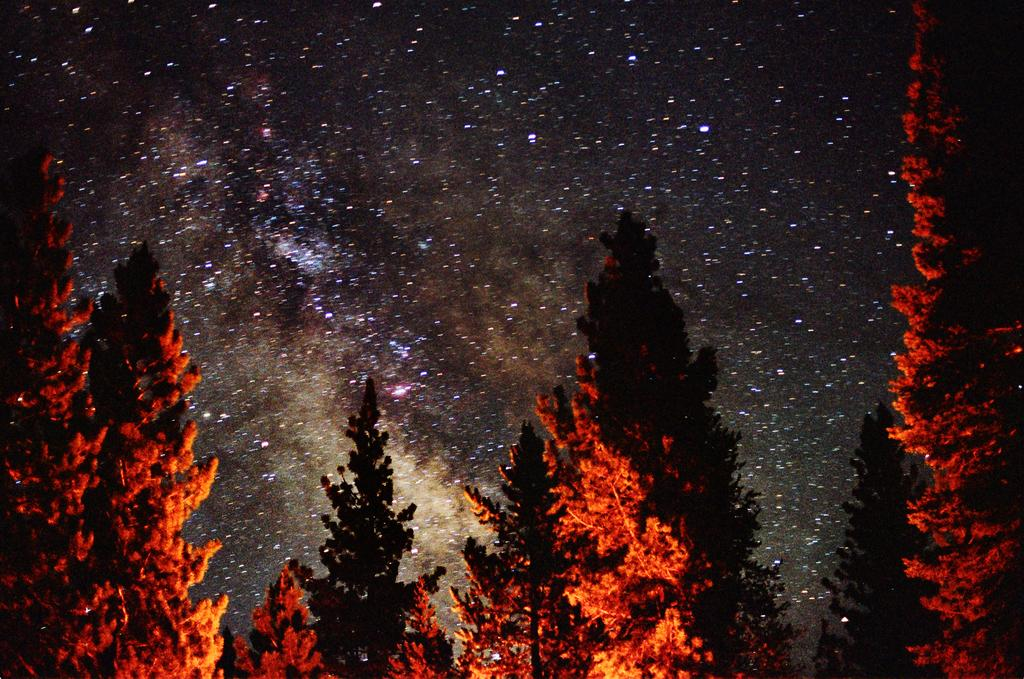What type of vegetation can be seen in the image? There are trees in the image. How is the light affecting the trees in the image? The trees have light on them in the image. What can be seen in the background of the image? The sky is visible in the background of the image. What celestial objects are present in the sky? Stars are present in the sky. Where is the basin located in the image? There is no basin present in the image. What type of root can be seen growing on the trees in the image? There is no root visible on the trees in the image. 